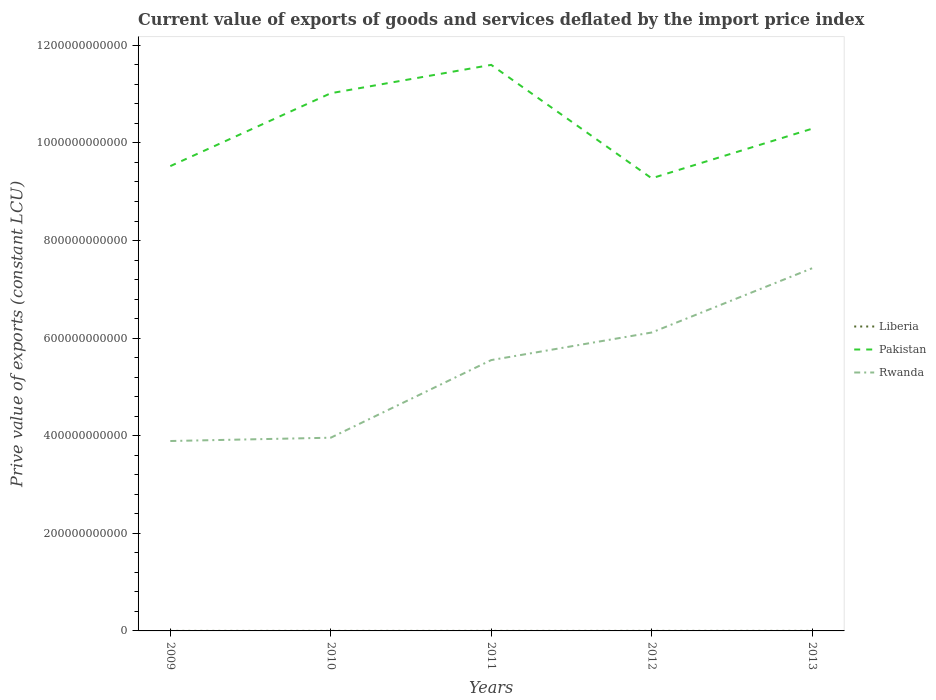How many different coloured lines are there?
Offer a terse response. 3. Is the number of lines equal to the number of legend labels?
Your answer should be very brief. Yes. Across all years, what is the maximum prive value of exports in Liberia?
Your response must be concise. 5.25e+07. In which year was the prive value of exports in Pakistan maximum?
Keep it short and to the point. 2012. What is the total prive value of exports in Liberia in the graph?
Ensure brevity in your answer.  -1.97e+07. What is the difference between the highest and the second highest prive value of exports in Liberia?
Keep it short and to the point. 4.98e+07. What is the difference between the highest and the lowest prive value of exports in Liberia?
Your answer should be compact. 2. Is the prive value of exports in Rwanda strictly greater than the prive value of exports in Pakistan over the years?
Make the answer very short. Yes. How many years are there in the graph?
Offer a terse response. 5. What is the difference between two consecutive major ticks on the Y-axis?
Provide a short and direct response. 2.00e+11. Are the values on the major ticks of Y-axis written in scientific E-notation?
Your answer should be compact. No. Does the graph contain grids?
Keep it short and to the point. No. Where does the legend appear in the graph?
Your answer should be very brief. Center right. How many legend labels are there?
Ensure brevity in your answer.  3. How are the legend labels stacked?
Your response must be concise. Vertical. What is the title of the graph?
Provide a succinct answer. Current value of exports of goods and services deflated by the import price index. What is the label or title of the Y-axis?
Offer a very short reply. Prive value of exports (constant LCU). What is the Prive value of exports (constant LCU) of Liberia in 2009?
Your answer should be very brief. 5.25e+07. What is the Prive value of exports (constant LCU) in Pakistan in 2009?
Provide a succinct answer. 9.52e+11. What is the Prive value of exports (constant LCU) in Rwanda in 2009?
Your answer should be very brief. 3.89e+11. What is the Prive value of exports (constant LCU) in Liberia in 2010?
Ensure brevity in your answer.  5.83e+07. What is the Prive value of exports (constant LCU) in Pakistan in 2010?
Give a very brief answer. 1.10e+12. What is the Prive value of exports (constant LCU) in Rwanda in 2010?
Keep it short and to the point. 3.96e+11. What is the Prive value of exports (constant LCU) of Liberia in 2011?
Provide a short and direct response. 6.47e+07. What is the Prive value of exports (constant LCU) in Pakistan in 2011?
Ensure brevity in your answer.  1.16e+12. What is the Prive value of exports (constant LCU) of Rwanda in 2011?
Make the answer very short. 5.55e+11. What is the Prive value of exports (constant LCU) of Liberia in 2012?
Give a very brief answer. 8.26e+07. What is the Prive value of exports (constant LCU) of Pakistan in 2012?
Provide a short and direct response. 9.28e+11. What is the Prive value of exports (constant LCU) in Rwanda in 2012?
Make the answer very short. 6.12e+11. What is the Prive value of exports (constant LCU) in Liberia in 2013?
Your answer should be compact. 1.02e+08. What is the Prive value of exports (constant LCU) of Pakistan in 2013?
Offer a terse response. 1.03e+12. What is the Prive value of exports (constant LCU) in Rwanda in 2013?
Ensure brevity in your answer.  7.43e+11. Across all years, what is the maximum Prive value of exports (constant LCU) of Liberia?
Give a very brief answer. 1.02e+08. Across all years, what is the maximum Prive value of exports (constant LCU) of Pakistan?
Your answer should be very brief. 1.16e+12. Across all years, what is the maximum Prive value of exports (constant LCU) of Rwanda?
Your response must be concise. 7.43e+11. Across all years, what is the minimum Prive value of exports (constant LCU) in Liberia?
Give a very brief answer. 5.25e+07. Across all years, what is the minimum Prive value of exports (constant LCU) in Pakistan?
Your answer should be very brief. 9.28e+11. Across all years, what is the minimum Prive value of exports (constant LCU) in Rwanda?
Provide a succinct answer. 3.89e+11. What is the total Prive value of exports (constant LCU) of Liberia in the graph?
Ensure brevity in your answer.  3.60e+08. What is the total Prive value of exports (constant LCU) of Pakistan in the graph?
Ensure brevity in your answer.  5.17e+12. What is the total Prive value of exports (constant LCU) of Rwanda in the graph?
Offer a very short reply. 2.69e+12. What is the difference between the Prive value of exports (constant LCU) of Liberia in 2009 and that in 2010?
Make the answer very short. -5.82e+06. What is the difference between the Prive value of exports (constant LCU) in Pakistan in 2009 and that in 2010?
Keep it short and to the point. -1.49e+11. What is the difference between the Prive value of exports (constant LCU) of Rwanda in 2009 and that in 2010?
Your answer should be compact. -6.77e+09. What is the difference between the Prive value of exports (constant LCU) in Liberia in 2009 and that in 2011?
Provide a succinct answer. -1.22e+07. What is the difference between the Prive value of exports (constant LCU) of Pakistan in 2009 and that in 2011?
Your answer should be compact. -2.07e+11. What is the difference between the Prive value of exports (constant LCU) in Rwanda in 2009 and that in 2011?
Give a very brief answer. -1.66e+11. What is the difference between the Prive value of exports (constant LCU) in Liberia in 2009 and that in 2012?
Ensure brevity in your answer.  -3.01e+07. What is the difference between the Prive value of exports (constant LCU) in Pakistan in 2009 and that in 2012?
Give a very brief answer. 2.50e+1. What is the difference between the Prive value of exports (constant LCU) in Rwanda in 2009 and that in 2012?
Provide a short and direct response. -2.22e+11. What is the difference between the Prive value of exports (constant LCU) in Liberia in 2009 and that in 2013?
Your answer should be compact. -4.98e+07. What is the difference between the Prive value of exports (constant LCU) of Pakistan in 2009 and that in 2013?
Give a very brief answer. -7.66e+1. What is the difference between the Prive value of exports (constant LCU) in Rwanda in 2009 and that in 2013?
Provide a short and direct response. -3.54e+11. What is the difference between the Prive value of exports (constant LCU) of Liberia in 2010 and that in 2011?
Provide a short and direct response. -6.36e+06. What is the difference between the Prive value of exports (constant LCU) of Pakistan in 2010 and that in 2011?
Keep it short and to the point. -5.81e+1. What is the difference between the Prive value of exports (constant LCU) of Rwanda in 2010 and that in 2011?
Offer a very short reply. -1.59e+11. What is the difference between the Prive value of exports (constant LCU) in Liberia in 2010 and that in 2012?
Offer a terse response. -2.43e+07. What is the difference between the Prive value of exports (constant LCU) in Pakistan in 2010 and that in 2012?
Your answer should be compact. 1.74e+11. What is the difference between the Prive value of exports (constant LCU) in Rwanda in 2010 and that in 2012?
Your answer should be very brief. -2.16e+11. What is the difference between the Prive value of exports (constant LCU) in Liberia in 2010 and that in 2013?
Provide a succinct answer. -4.40e+07. What is the difference between the Prive value of exports (constant LCU) of Pakistan in 2010 and that in 2013?
Provide a succinct answer. 7.27e+1. What is the difference between the Prive value of exports (constant LCU) in Rwanda in 2010 and that in 2013?
Offer a terse response. -3.47e+11. What is the difference between the Prive value of exports (constant LCU) of Liberia in 2011 and that in 2012?
Your answer should be very brief. -1.79e+07. What is the difference between the Prive value of exports (constant LCU) of Pakistan in 2011 and that in 2012?
Your response must be concise. 2.32e+11. What is the difference between the Prive value of exports (constant LCU) of Rwanda in 2011 and that in 2012?
Your answer should be very brief. -5.65e+1. What is the difference between the Prive value of exports (constant LCU) of Liberia in 2011 and that in 2013?
Ensure brevity in your answer.  -3.76e+07. What is the difference between the Prive value of exports (constant LCU) of Pakistan in 2011 and that in 2013?
Provide a succinct answer. 1.31e+11. What is the difference between the Prive value of exports (constant LCU) of Rwanda in 2011 and that in 2013?
Keep it short and to the point. -1.88e+11. What is the difference between the Prive value of exports (constant LCU) of Liberia in 2012 and that in 2013?
Keep it short and to the point. -1.97e+07. What is the difference between the Prive value of exports (constant LCU) in Pakistan in 2012 and that in 2013?
Your response must be concise. -1.02e+11. What is the difference between the Prive value of exports (constant LCU) in Rwanda in 2012 and that in 2013?
Your answer should be compact. -1.32e+11. What is the difference between the Prive value of exports (constant LCU) of Liberia in 2009 and the Prive value of exports (constant LCU) of Pakistan in 2010?
Make the answer very short. -1.10e+12. What is the difference between the Prive value of exports (constant LCU) in Liberia in 2009 and the Prive value of exports (constant LCU) in Rwanda in 2010?
Your answer should be very brief. -3.96e+11. What is the difference between the Prive value of exports (constant LCU) in Pakistan in 2009 and the Prive value of exports (constant LCU) in Rwanda in 2010?
Provide a succinct answer. 5.57e+11. What is the difference between the Prive value of exports (constant LCU) in Liberia in 2009 and the Prive value of exports (constant LCU) in Pakistan in 2011?
Your answer should be very brief. -1.16e+12. What is the difference between the Prive value of exports (constant LCU) in Liberia in 2009 and the Prive value of exports (constant LCU) in Rwanda in 2011?
Provide a succinct answer. -5.55e+11. What is the difference between the Prive value of exports (constant LCU) of Pakistan in 2009 and the Prive value of exports (constant LCU) of Rwanda in 2011?
Keep it short and to the point. 3.97e+11. What is the difference between the Prive value of exports (constant LCU) of Liberia in 2009 and the Prive value of exports (constant LCU) of Pakistan in 2012?
Make the answer very short. -9.27e+11. What is the difference between the Prive value of exports (constant LCU) in Liberia in 2009 and the Prive value of exports (constant LCU) in Rwanda in 2012?
Make the answer very short. -6.11e+11. What is the difference between the Prive value of exports (constant LCU) of Pakistan in 2009 and the Prive value of exports (constant LCU) of Rwanda in 2012?
Make the answer very short. 3.41e+11. What is the difference between the Prive value of exports (constant LCU) in Liberia in 2009 and the Prive value of exports (constant LCU) in Pakistan in 2013?
Make the answer very short. -1.03e+12. What is the difference between the Prive value of exports (constant LCU) of Liberia in 2009 and the Prive value of exports (constant LCU) of Rwanda in 2013?
Your answer should be compact. -7.43e+11. What is the difference between the Prive value of exports (constant LCU) of Pakistan in 2009 and the Prive value of exports (constant LCU) of Rwanda in 2013?
Keep it short and to the point. 2.09e+11. What is the difference between the Prive value of exports (constant LCU) of Liberia in 2010 and the Prive value of exports (constant LCU) of Pakistan in 2011?
Your answer should be very brief. -1.16e+12. What is the difference between the Prive value of exports (constant LCU) in Liberia in 2010 and the Prive value of exports (constant LCU) in Rwanda in 2011?
Your answer should be compact. -5.55e+11. What is the difference between the Prive value of exports (constant LCU) in Pakistan in 2010 and the Prive value of exports (constant LCU) in Rwanda in 2011?
Provide a succinct answer. 5.47e+11. What is the difference between the Prive value of exports (constant LCU) in Liberia in 2010 and the Prive value of exports (constant LCU) in Pakistan in 2012?
Keep it short and to the point. -9.27e+11. What is the difference between the Prive value of exports (constant LCU) of Liberia in 2010 and the Prive value of exports (constant LCU) of Rwanda in 2012?
Ensure brevity in your answer.  -6.11e+11. What is the difference between the Prive value of exports (constant LCU) in Pakistan in 2010 and the Prive value of exports (constant LCU) in Rwanda in 2012?
Provide a short and direct response. 4.90e+11. What is the difference between the Prive value of exports (constant LCU) of Liberia in 2010 and the Prive value of exports (constant LCU) of Pakistan in 2013?
Your answer should be very brief. -1.03e+12. What is the difference between the Prive value of exports (constant LCU) of Liberia in 2010 and the Prive value of exports (constant LCU) of Rwanda in 2013?
Provide a short and direct response. -7.43e+11. What is the difference between the Prive value of exports (constant LCU) of Pakistan in 2010 and the Prive value of exports (constant LCU) of Rwanda in 2013?
Your answer should be compact. 3.59e+11. What is the difference between the Prive value of exports (constant LCU) of Liberia in 2011 and the Prive value of exports (constant LCU) of Pakistan in 2012?
Make the answer very short. -9.27e+11. What is the difference between the Prive value of exports (constant LCU) of Liberia in 2011 and the Prive value of exports (constant LCU) of Rwanda in 2012?
Your response must be concise. -6.11e+11. What is the difference between the Prive value of exports (constant LCU) in Pakistan in 2011 and the Prive value of exports (constant LCU) in Rwanda in 2012?
Provide a short and direct response. 5.48e+11. What is the difference between the Prive value of exports (constant LCU) of Liberia in 2011 and the Prive value of exports (constant LCU) of Pakistan in 2013?
Offer a very short reply. -1.03e+12. What is the difference between the Prive value of exports (constant LCU) of Liberia in 2011 and the Prive value of exports (constant LCU) of Rwanda in 2013?
Ensure brevity in your answer.  -7.43e+11. What is the difference between the Prive value of exports (constant LCU) in Pakistan in 2011 and the Prive value of exports (constant LCU) in Rwanda in 2013?
Keep it short and to the point. 4.17e+11. What is the difference between the Prive value of exports (constant LCU) in Liberia in 2012 and the Prive value of exports (constant LCU) in Pakistan in 2013?
Offer a very short reply. -1.03e+12. What is the difference between the Prive value of exports (constant LCU) of Liberia in 2012 and the Prive value of exports (constant LCU) of Rwanda in 2013?
Provide a short and direct response. -7.43e+11. What is the difference between the Prive value of exports (constant LCU) of Pakistan in 2012 and the Prive value of exports (constant LCU) of Rwanda in 2013?
Your response must be concise. 1.84e+11. What is the average Prive value of exports (constant LCU) of Liberia per year?
Your answer should be compact. 7.21e+07. What is the average Prive value of exports (constant LCU) in Pakistan per year?
Provide a succinct answer. 1.03e+12. What is the average Prive value of exports (constant LCU) of Rwanda per year?
Your answer should be compact. 5.39e+11. In the year 2009, what is the difference between the Prive value of exports (constant LCU) of Liberia and Prive value of exports (constant LCU) of Pakistan?
Offer a terse response. -9.52e+11. In the year 2009, what is the difference between the Prive value of exports (constant LCU) of Liberia and Prive value of exports (constant LCU) of Rwanda?
Offer a terse response. -3.89e+11. In the year 2009, what is the difference between the Prive value of exports (constant LCU) of Pakistan and Prive value of exports (constant LCU) of Rwanda?
Your answer should be very brief. 5.63e+11. In the year 2010, what is the difference between the Prive value of exports (constant LCU) in Liberia and Prive value of exports (constant LCU) in Pakistan?
Your answer should be very brief. -1.10e+12. In the year 2010, what is the difference between the Prive value of exports (constant LCU) in Liberia and Prive value of exports (constant LCU) in Rwanda?
Offer a terse response. -3.96e+11. In the year 2010, what is the difference between the Prive value of exports (constant LCU) in Pakistan and Prive value of exports (constant LCU) in Rwanda?
Make the answer very short. 7.06e+11. In the year 2011, what is the difference between the Prive value of exports (constant LCU) of Liberia and Prive value of exports (constant LCU) of Pakistan?
Your answer should be compact. -1.16e+12. In the year 2011, what is the difference between the Prive value of exports (constant LCU) in Liberia and Prive value of exports (constant LCU) in Rwanda?
Keep it short and to the point. -5.55e+11. In the year 2011, what is the difference between the Prive value of exports (constant LCU) of Pakistan and Prive value of exports (constant LCU) of Rwanda?
Offer a terse response. 6.05e+11. In the year 2012, what is the difference between the Prive value of exports (constant LCU) of Liberia and Prive value of exports (constant LCU) of Pakistan?
Offer a terse response. -9.27e+11. In the year 2012, what is the difference between the Prive value of exports (constant LCU) of Liberia and Prive value of exports (constant LCU) of Rwanda?
Provide a short and direct response. -6.11e+11. In the year 2012, what is the difference between the Prive value of exports (constant LCU) of Pakistan and Prive value of exports (constant LCU) of Rwanda?
Provide a short and direct response. 3.16e+11. In the year 2013, what is the difference between the Prive value of exports (constant LCU) of Liberia and Prive value of exports (constant LCU) of Pakistan?
Your response must be concise. -1.03e+12. In the year 2013, what is the difference between the Prive value of exports (constant LCU) of Liberia and Prive value of exports (constant LCU) of Rwanda?
Provide a short and direct response. -7.43e+11. In the year 2013, what is the difference between the Prive value of exports (constant LCU) of Pakistan and Prive value of exports (constant LCU) of Rwanda?
Provide a succinct answer. 2.86e+11. What is the ratio of the Prive value of exports (constant LCU) of Liberia in 2009 to that in 2010?
Offer a terse response. 0.9. What is the ratio of the Prive value of exports (constant LCU) of Pakistan in 2009 to that in 2010?
Provide a short and direct response. 0.86. What is the ratio of the Prive value of exports (constant LCU) in Rwanda in 2009 to that in 2010?
Your answer should be very brief. 0.98. What is the ratio of the Prive value of exports (constant LCU) of Liberia in 2009 to that in 2011?
Provide a succinct answer. 0.81. What is the ratio of the Prive value of exports (constant LCU) in Pakistan in 2009 to that in 2011?
Offer a terse response. 0.82. What is the ratio of the Prive value of exports (constant LCU) in Rwanda in 2009 to that in 2011?
Provide a succinct answer. 0.7. What is the ratio of the Prive value of exports (constant LCU) in Liberia in 2009 to that in 2012?
Your answer should be very brief. 0.64. What is the ratio of the Prive value of exports (constant LCU) of Pakistan in 2009 to that in 2012?
Offer a terse response. 1.03. What is the ratio of the Prive value of exports (constant LCU) in Rwanda in 2009 to that in 2012?
Provide a short and direct response. 0.64. What is the ratio of the Prive value of exports (constant LCU) in Liberia in 2009 to that in 2013?
Keep it short and to the point. 0.51. What is the ratio of the Prive value of exports (constant LCU) in Pakistan in 2009 to that in 2013?
Make the answer very short. 0.93. What is the ratio of the Prive value of exports (constant LCU) in Rwanda in 2009 to that in 2013?
Your response must be concise. 0.52. What is the ratio of the Prive value of exports (constant LCU) in Liberia in 2010 to that in 2011?
Your answer should be compact. 0.9. What is the ratio of the Prive value of exports (constant LCU) in Pakistan in 2010 to that in 2011?
Offer a terse response. 0.95. What is the ratio of the Prive value of exports (constant LCU) of Rwanda in 2010 to that in 2011?
Provide a succinct answer. 0.71. What is the ratio of the Prive value of exports (constant LCU) of Liberia in 2010 to that in 2012?
Your response must be concise. 0.71. What is the ratio of the Prive value of exports (constant LCU) of Pakistan in 2010 to that in 2012?
Provide a succinct answer. 1.19. What is the ratio of the Prive value of exports (constant LCU) in Rwanda in 2010 to that in 2012?
Your answer should be compact. 0.65. What is the ratio of the Prive value of exports (constant LCU) of Liberia in 2010 to that in 2013?
Offer a very short reply. 0.57. What is the ratio of the Prive value of exports (constant LCU) in Pakistan in 2010 to that in 2013?
Ensure brevity in your answer.  1.07. What is the ratio of the Prive value of exports (constant LCU) of Rwanda in 2010 to that in 2013?
Give a very brief answer. 0.53. What is the ratio of the Prive value of exports (constant LCU) of Liberia in 2011 to that in 2012?
Give a very brief answer. 0.78. What is the ratio of the Prive value of exports (constant LCU) of Pakistan in 2011 to that in 2012?
Give a very brief answer. 1.25. What is the ratio of the Prive value of exports (constant LCU) of Rwanda in 2011 to that in 2012?
Ensure brevity in your answer.  0.91. What is the ratio of the Prive value of exports (constant LCU) of Liberia in 2011 to that in 2013?
Offer a very short reply. 0.63. What is the ratio of the Prive value of exports (constant LCU) in Pakistan in 2011 to that in 2013?
Keep it short and to the point. 1.13. What is the ratio of the Prive value of exports (constant LCU) in Rwanda in 2011 to that in 2013?
Provide a short and direct response. 0.75. What is the ratio of the Prive value of exports (constant LCU) in Liberia in 2012 to that in 2013?
Make the answer very short. 0.81. What is the ratio of the Prive value of exports (constant LCU) of Pakistan in 2012 to that in 2013?
Keep it short and to the point. 0.9. What is the ratio of the Prive value of exports (constant LCU) in Rwanda in 2012 to that in 2013?
Provide a short and direct response. 0.82. What is the difference between the highest and the second highest Prive value of exports (constant LCU) in Liberia?
Ensure brevity in your answer.  1.97e+07. What is the difference between the highest and the second highest Prive value of exports (constant LCU) of Pakistan?
Make the answer very short. 5.81e+1. What is the difference between the highest and the second highest Prive value of exports (constant LCU) of Rwanda?
Keep it short and to the point. 1.32e+11. What is the difference between the highest and the lowest Prive value of exports (constant LCU) in Liberia?
Make the answer very short. 4.98e+07. What is the difference between the highest and the lowest Prive value of exports (constant LCU) in Pakistan?
Make the answer very short. 2.32e+11. What is the difference between the highest and the lowest Prive value of exports (constant LCU) in Rwanda?
Your answer should be very brief. 3.54e+11. 